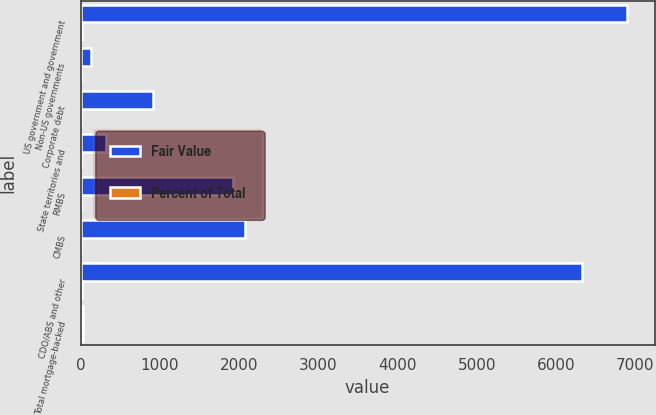Convert chart. <chart><loc_0><loc_0><loc_500><loc_500><stacked_bar_chart><ecel><fcel>US government and government<fcel>Non-US governments<fcel>Corporate debt<fcel>State territories and<fcel>RMBS<fcel>CMBS<fcel>CDO/ABS and other<fcel>Total mortgage-backed<nl><fcel>Fair Value<fcel>6902<fcel>125<fcel>912<fcel>316<fcel>1928<fcel>2078<fcel>6331<fcel>31<nl><fcel>Percent of Total<fcel>21<fcel>1<fcel>3<fcel>1<fcel>6<fcel>6<fcel>19<fcel>31<nl></chart> 